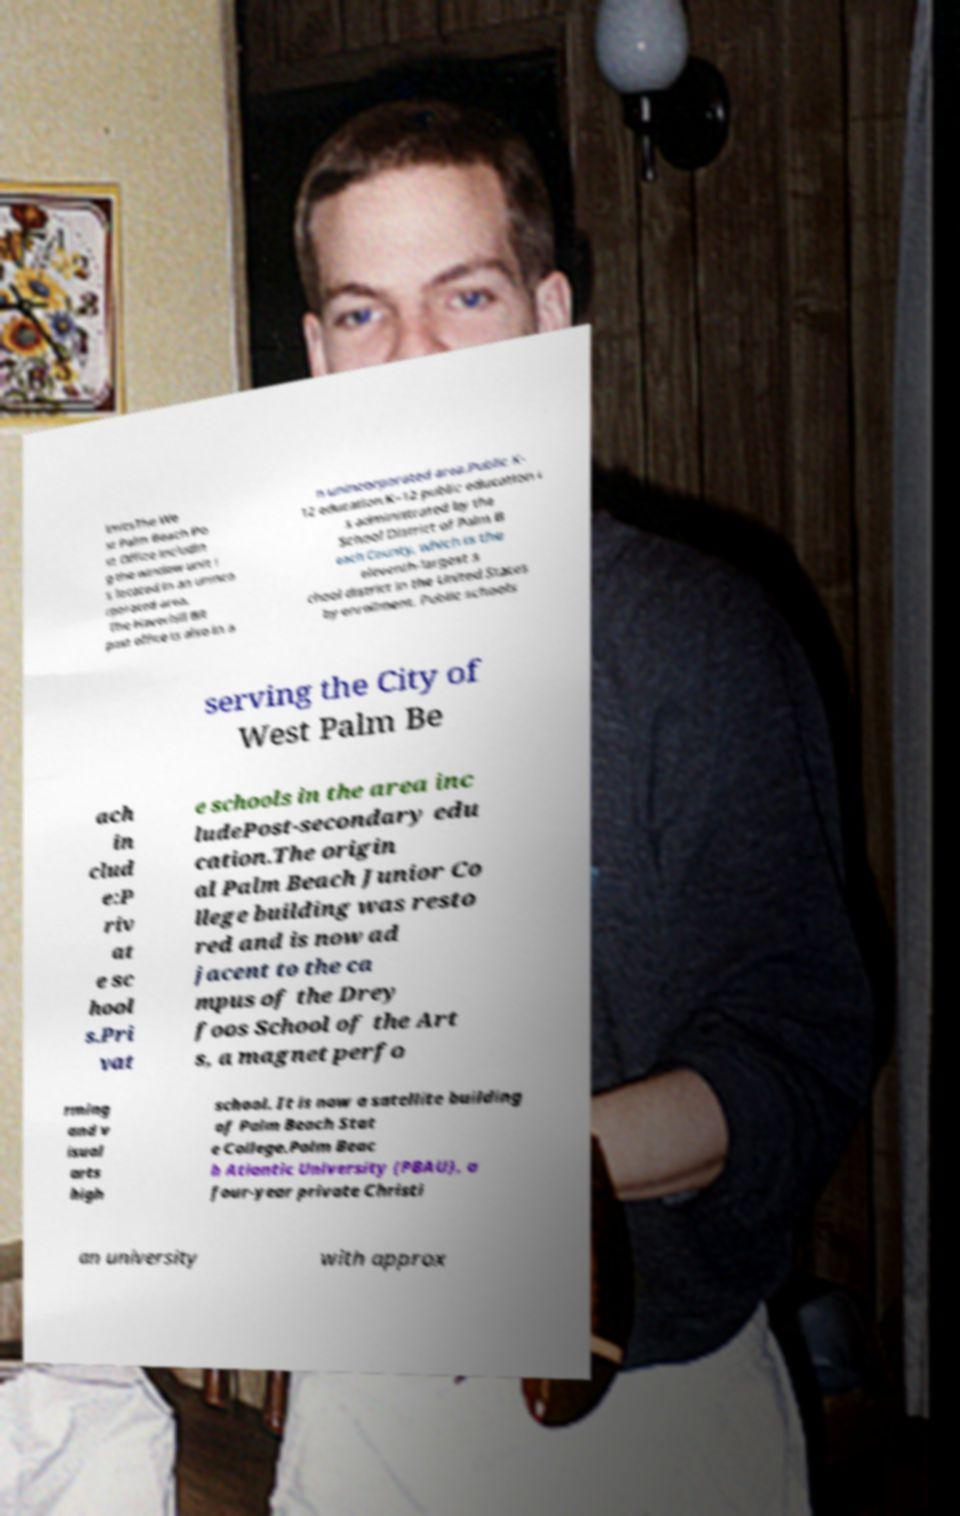Could you assist in decoding the text presented in this image and type it out clearly? imitsThe We st Palm Beach Po st Office includin g the window unit i s located in an uninco rporated area. The Haverhill BR post office is also in a n unincorporated area.Public K- 12 education.K–12 public education i s administrated by the School District of Palm B each County, which is the eleventh-largest s chool district in the United States by enrollment. Public schools serving the City of West Palm Be ach in clud e:P riv at e sc hool s.Pri vat e schools in the area inc ludePost-secondary edu cation.The origin al Palm Beach Junior Co llege building was resto red and is now ad jacent to the ca mpus of the Drey foos School of the Art s, a magnet perfo rming and v isual arts high school. It is now a satellite building of Palm Beach Stat e College.Palm Beac h Atlantic University (PBAU), a four-year private Christi an university with approx 